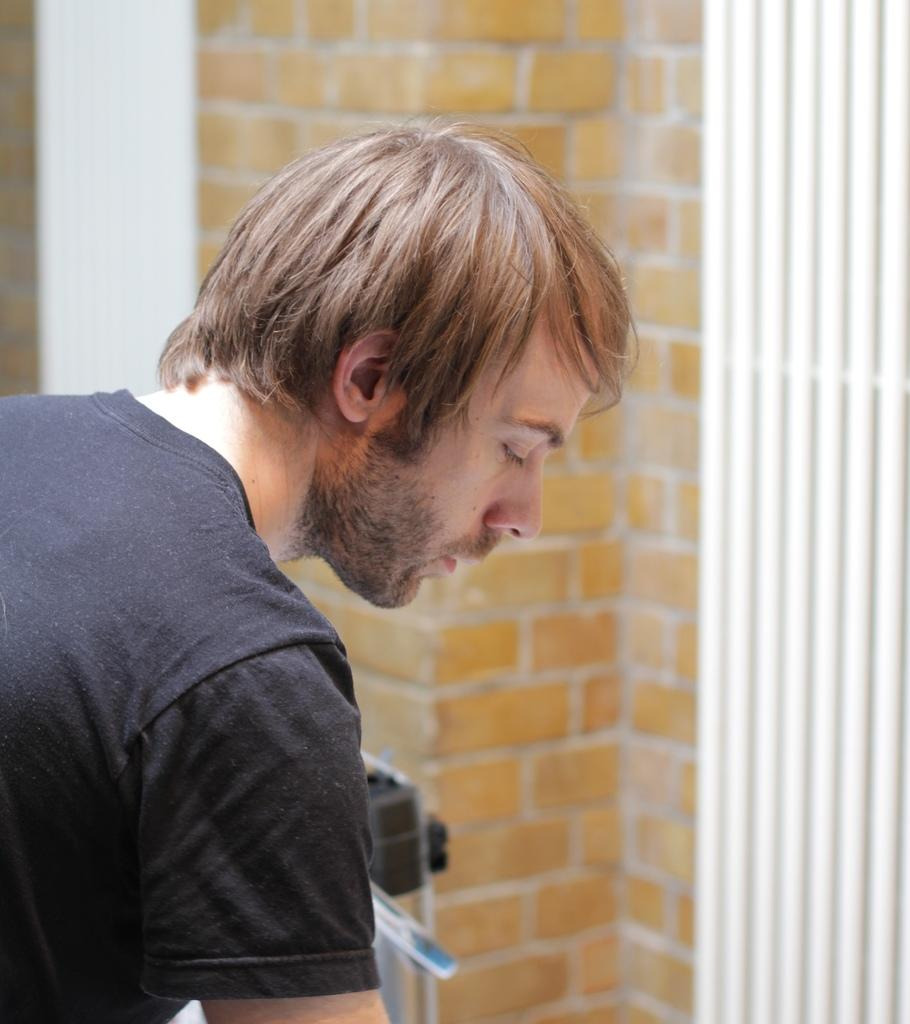Who or what is present in the image? There is a person in the image. What can be seen in the background of the image? There is a brick wall with white color pipes in the image. What is in front of the person? There is an object in front of the person. What type of dress is the scarecrow wearing in the image? There is no scarecrow present in the image, and therefore no dress can be observed. 